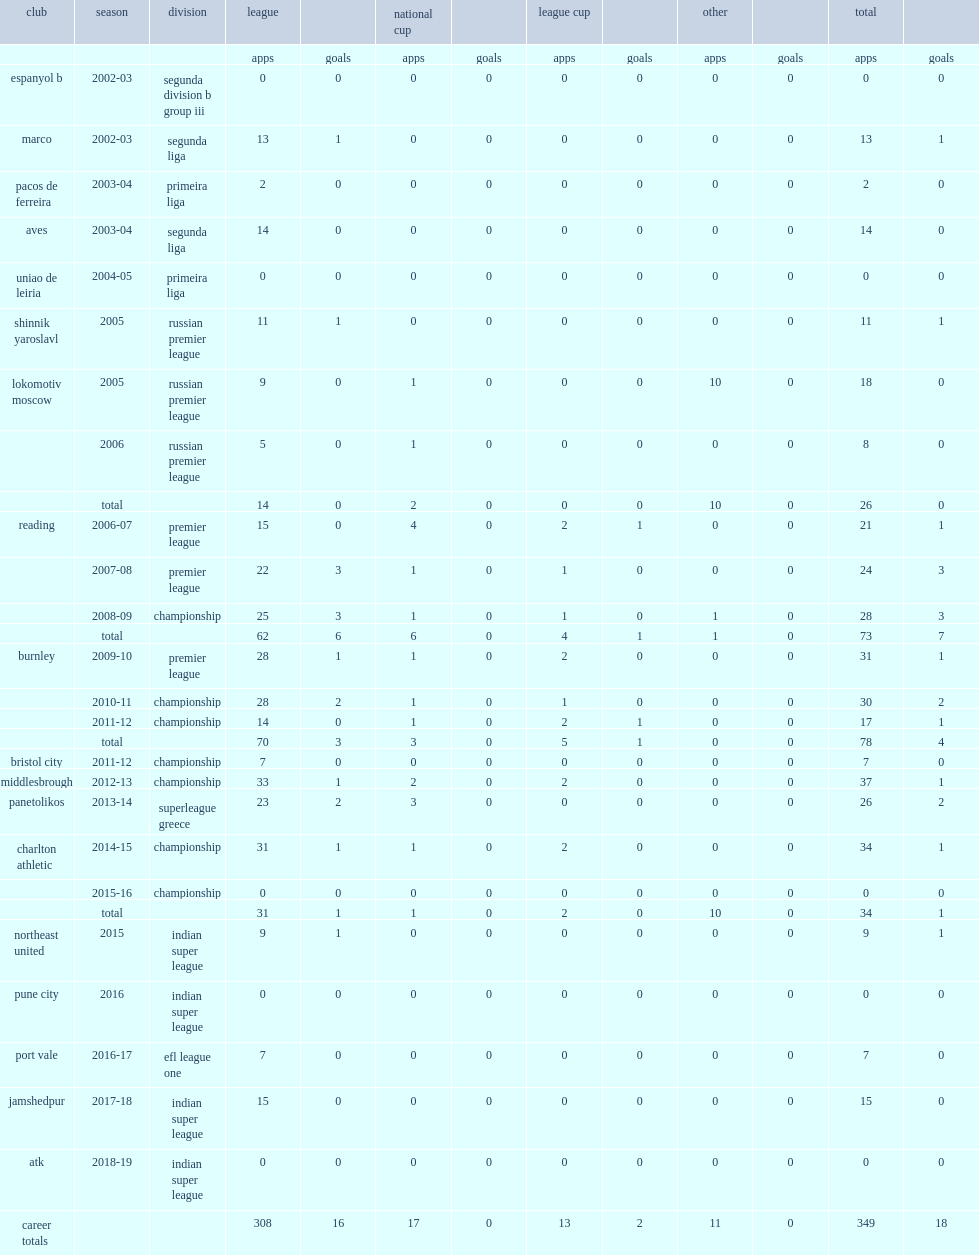Which club did bikey play for in 2016-17? Port vale. 